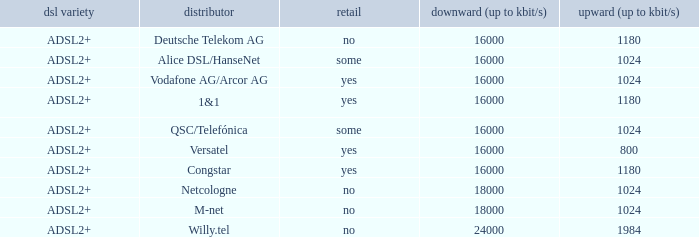What is download bandwith where the provider is deutsche telekom ag? 16000.0. 